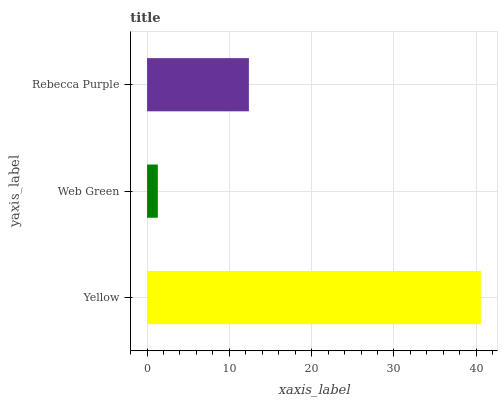Is Web Green the minimum?
Answer yes or no. Yes. Is Yellow the maximum?
Answer yes or no. Yes. Is Rebecca Purple the minimum?
Answer yes or no. No. Is Rebecca Purple the maximum?
Answer yes or no. No. Is Rebecca Purple greater than Web Green?
Answer yes or no. Yes. Is Web Green less than Rebecca Purple?
Answer yes or no. Yes. Is Web Green greater than Rebecca Purple?
Answer yes or no. No. Is Rebecca Purple less than Web Green?
Answer yes or no. No. Is Rebecca Purple the high median?
Answer yes or no. Yes. Is Rebecca Purple the low median?
Answer yes or no. Yes. Is Web Green the high median?
Answer yes or no. No. Is Yellow the low median?
Answer yes or no. No. 